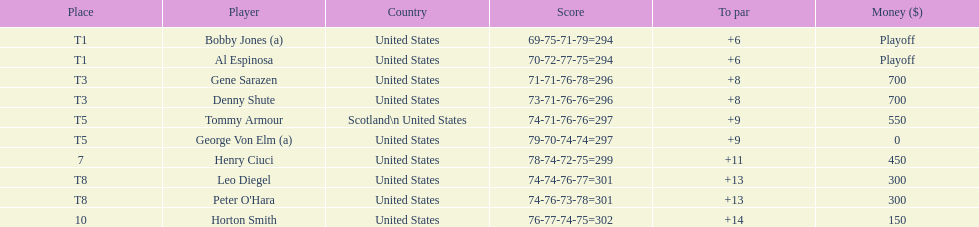Who was the final player to enter the top 10? Horton Smith. 